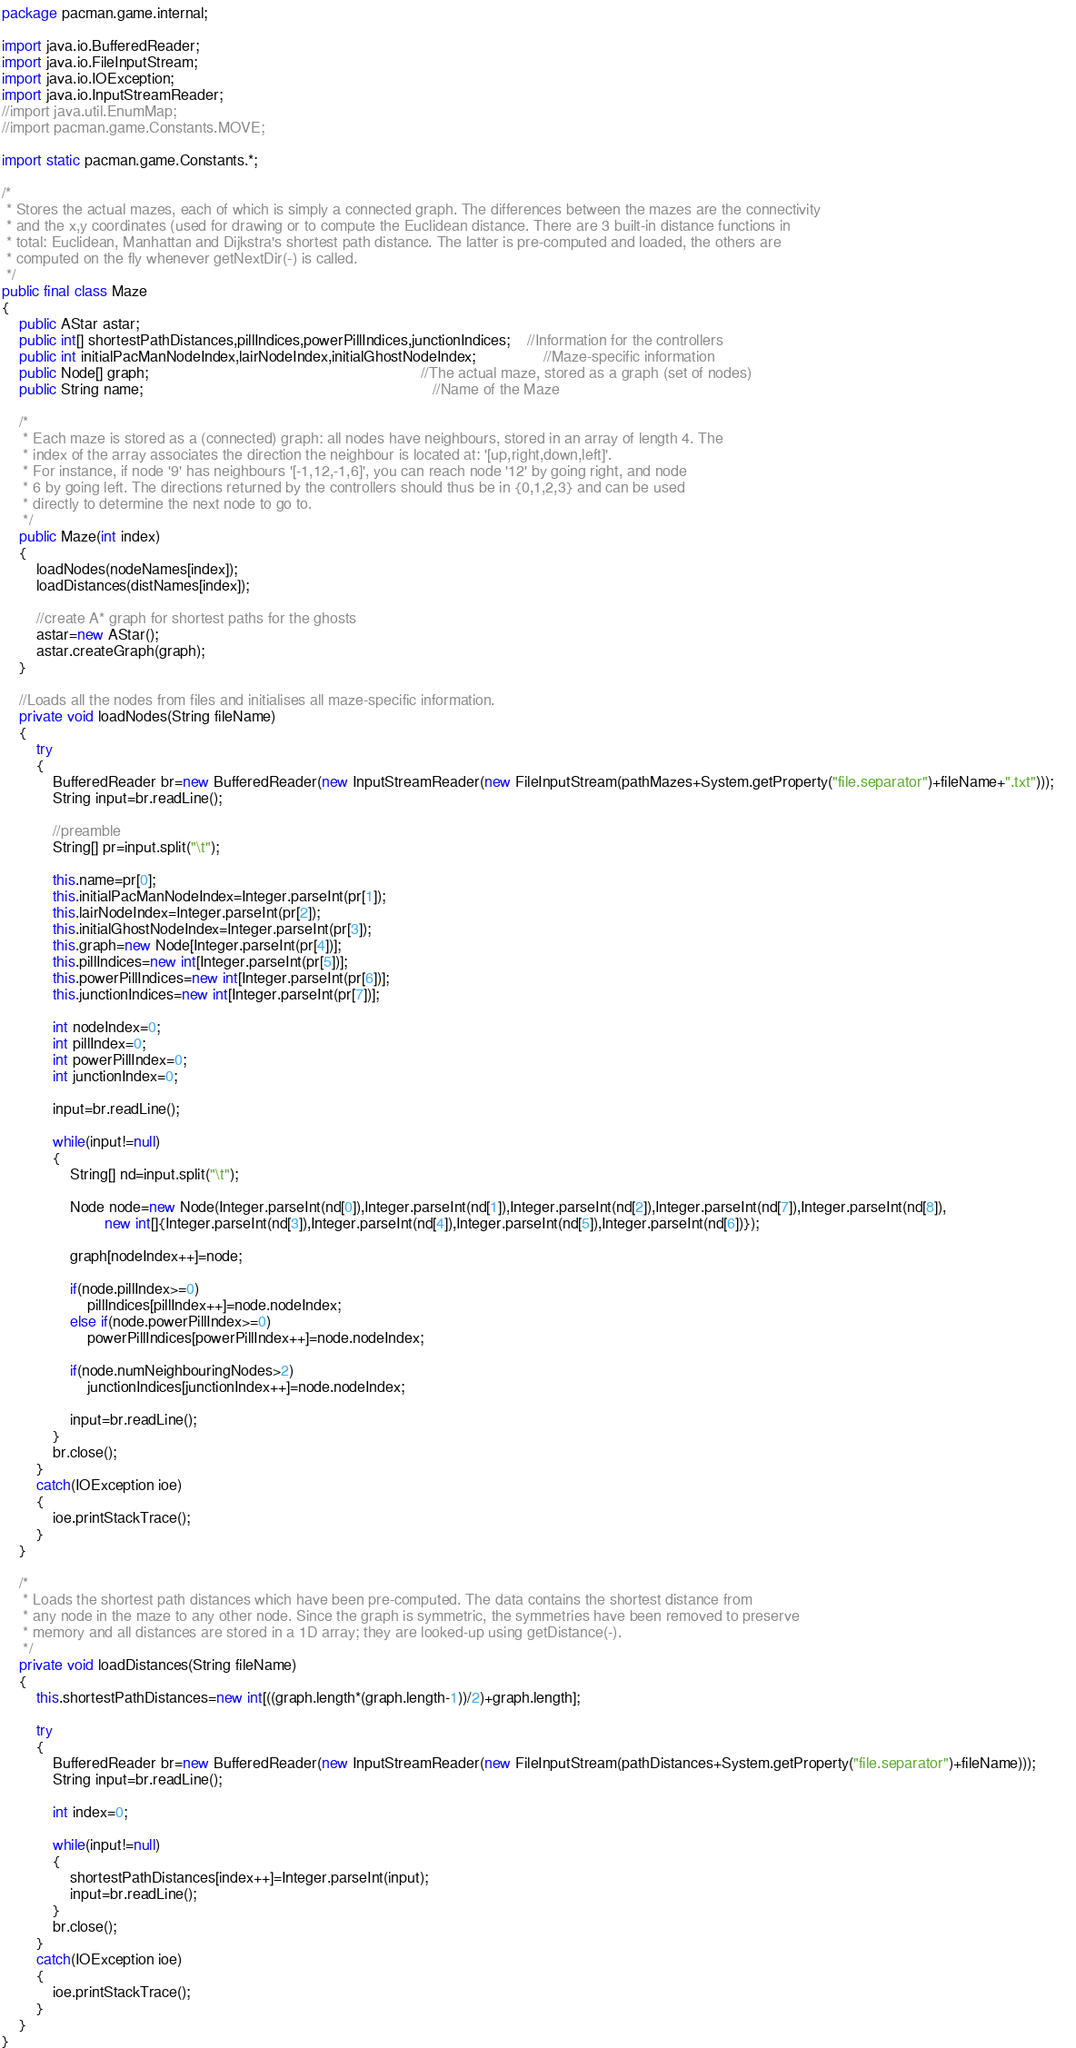Convert code to text. <code><loc_0><loc_0><loc_500><loc_500><_Java_>package pacman.game.internal;

import java.io.BufferedReader;
import java.io.FileInputStream;
import java.io.IOException;
import java.io.InputStreamReader;
//import java.util.EnumMap;
//import pacman.game.Constants.MOVE;

import static pacman.game.Constants.*;

/*
 * Stores the actual mazes, each of which is simply a connected graph. The differences between the mazes are the connectivity
 * and the x,y coordinates (used for drawing or to compute the Euclidean distance. There are 3 built-in distance functions in
 * total: Euclidean, Manhattan and Dijkstra's shortest path distance. The latter is pre-computed and loaded, the others are
 * computed on the fly whenever getNextDir(-) is called.
 */
public final class Maze
{
	public AStar astar;
	public int[] shortestPathDistances,pillIndices,powerPillIndices,junctionIndices;	//Information for the controllers
	public int initialPacManNodeIndex,lairNodeIndex,initialGhostNodeIndex;				//Maze-specific information
	public Node[] graph;																//The actual maze, stored as a graph (set of nodes)
	public String name;																	//Name of the Maze
	
	/*
	 * Each maze is stored as a (connected) graph: all nodes have neighbours, stored in an array of length 4. The
	 * index of the array associates the direction the neighbour is located at: '[up,right,down,left]'.
	 * For instance, if node '9' has neighbours '[-1,12,-1,6]', you can reach node '12' by going right, and node
	 * 6 by going left. The directions returned by the controllers should thus be in {0,1,2,3} and can be used
	 * directly to determine the next node to go to.
	 */		
	public Maze(int index)
	{
		loadNodes(nodeNames[index]);
		loadDistances(distNames[index]);
		
		//create A* graph for shortest paths for the ghosts
		astar=new AStar();
		astar.createGraph(graph);
	}
	
	//Loads all the nodes from files and initialises all maze-specific information.
	private void loadNodes(String fileName)
	{
        try
        {         	
        	BufferedReader br=new BufferedReader(new InputStreamReader(new FileInputStream(pathMazes+System.getProperty("file.separator")+fileName+".txt")));	 
            String input=br.readLine();		
            
            //preamble
            String[] pr=input.split("\t");
            
            this.name=pr[0];
            this.initialPacManNodeIndex=Integer.parseInt(pr[1]);
            this.lairNodeIndex=Integer.parseInt(pr[2]);
            this.initialGhostNodeIndex=Integer.parseInt(pr[3]);	            
            this.graph=new Node[Integer.parseInt(pr[4])];	            
            this.pillIndices=new int[Integer.parseInt(pr[5])];
            this.powerPillIndices=new int[Integer.parseInt(pr[6])];
            this.junctionIndices=new int[Integer.parseInt(pr[7])];        

            int nodeIndex=0;
        	int pillIndex=0;
        	int powerPillIndex=0;	        	
        	int junctionIndex=0;

            input=br.readLine();
        	
            while(input!=null)
            {	
                String[] nd=input.split("\t");
                
                Node node=new Node(Integer.parseInt(nd[0]),Integer.parseInt(nd[1]),Integer.parseInt(nd[2]),Integer.parseInt(nd[7]),Integer.parseInt(nd[8]),
                		new int[]{Integer.parseInt(nd[3]),Integer.parseInt(nd[4]),Integer.parseInt(nd[5]),Integer.parseInt(nd[6])});
                
                graph[nodeIndex++]=node;
                
                if(node.pillIndex>=0)
                	pillIndices[pillIndex++]=node.nodeIndex;
                else if(node.powerPillIndex>=0)
                	powerPillIndices[powerPillIndex++]=node.nodeIndex;
                
                if(node.numNeighbouringNodes>2)
                	junctionIndices[junctionIndex++]=node.nodeIndex;
                
                input=br.readLine();
            }
            br.close();
        }
        catch(IOException ioe)
        {
            ioe.printStackTrace();
        }
	}
	
	/*
	 * Loads the shortest path distances which have been pre-computed. The data contains the shortest distance from
	 * any node in the maze to any other node. Since the graph is symmetric, the symmetries have been removed to preserve
	 * memory and all distances are stored in a 1D array; they are looked-up using getDistance(-). 
	 */
	private void loadDistances(String fileName)
	{
		this.shortestPathDistances=new int[((graph.length*(graph.length-1))/2)+graph.length];
		
        try
        {
        	BufferedReader br=new BufferedReader(new InputStreamReader(new FileInputStream(pathDistances+System.getProperty("file.separator")+fileName)));
            String input=br.readLine();
            
            int index=0;
            
            while(input!=null)
            {	
            	shortestPathDistances[index++]=Integer.parseInt(input);
                input=br.readLine();
            }
            br.close();
        }
        catch(IOException ioe)
        {
            ioe.printStackTrace();
        }
	}
}</code> 